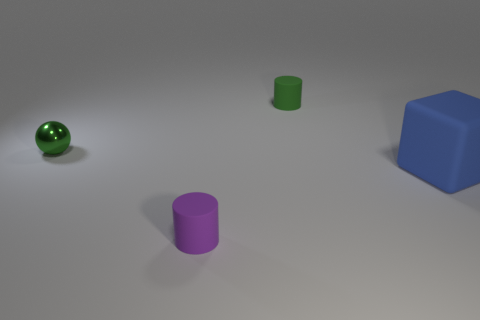Subtract all green cylinders. How many cylinders are left? 1 Subtract all small cyan shiny balls. Subtract all cylinders. How many objects are left? 2 Add 2 blue rubber things. How many blue rubber things are left? 3 Add 1 yellow objects. How many yellow objects exist? 1 Add 1 purple objects. How many objects exist? 5 Subtract 0 gray cubes. How many objects are left? 4 Subtract all cubes. How many objects are left? 3 Subtract all green blocks. Subtract all blue balls. How many blocks are left? 1 Subtract all gray spheres. How many gray cubes are left? 0 